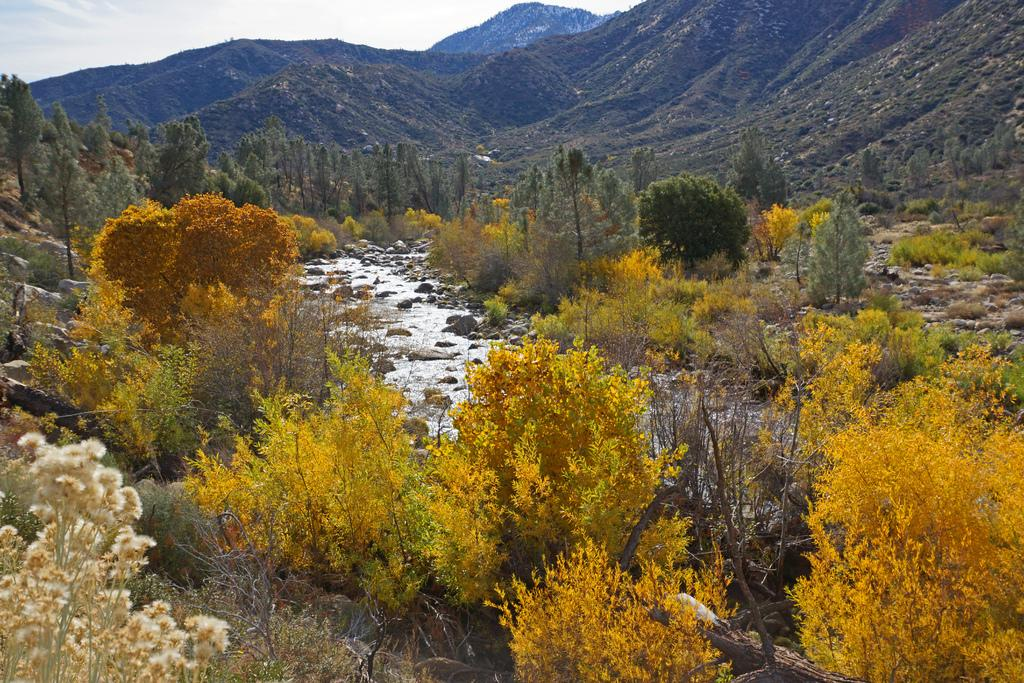What type of natural elements can be seen in the image? There are trees, a canal, and mountains visible in the image. Can you describe the landscape in the image? The image features a landscape with trees, a canal, and mountains. What type of water body is present in the image? There is a canal in the image. What geographical features are visible in the background of the image? Mountains can be seen in the background of the image. What type of doll can be seen playing on the street in the image? There is no doll or street present in the image; it features trees, a canal, and mountains. What type of observation can be made about the weather in the image? The image does not provide any information about the weather, as it only shows trees, a canal, and mountains. 